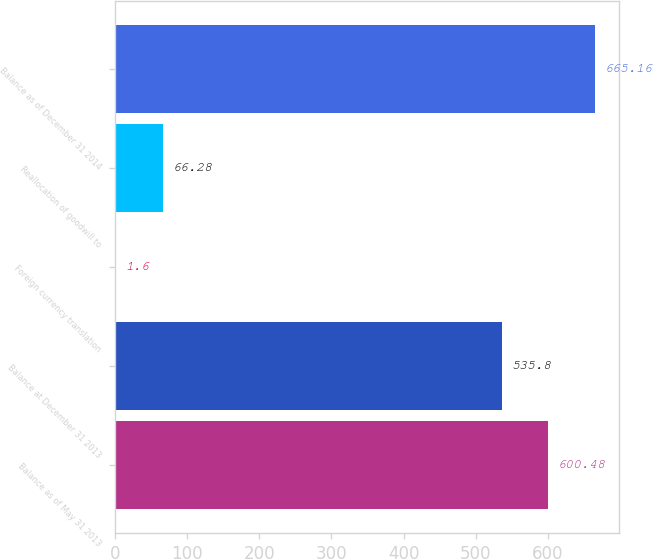<chart> <loc_0><loc_0><loc_500><loc_500><bar_chart><fcel>Balance as of May 31 2013<fcel>Balance at December 31 2013<fcel>Foreign currency translation<fcel>Reallocation of goodwill to<fcel>Balance as of December 31 2014<nl><fcel>600.48<fcel>535.8<fcel>1.6<fcel>66.28<fcel>665.16<nl></chart> 